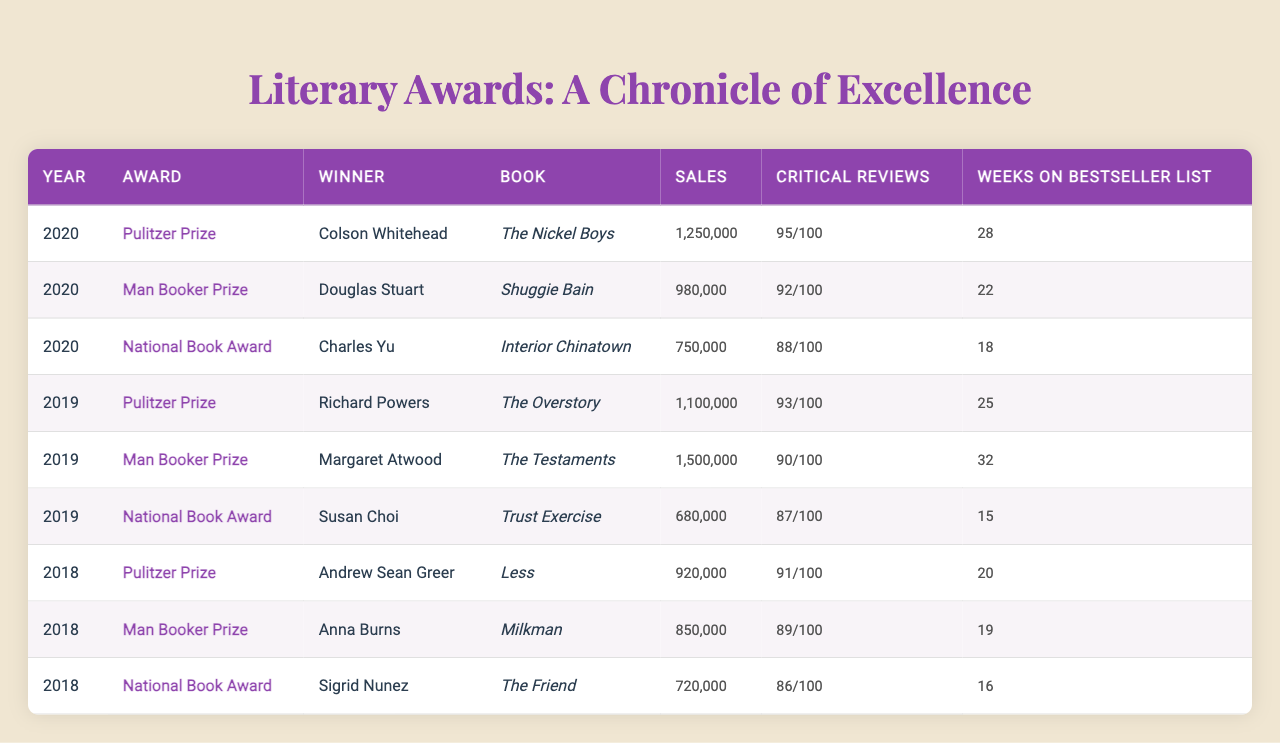What book won the Pulitzer Prize in 2020? In the table, I can see that the winner of the Pulitzer Prize in 2020 is listed as "Colson Whitehead" with the book "The Nickel Boys."
Answer: The Nickel Boys Which book had the highest sales in 2019? The table shows that "The Testaments" by Margaret Atwood had sales of 1,500,000, which is the highest among all listed books for that year.
Answer: The Testaments How many weeks did "Interior Chinatown" stay on the bestseller list? According to the table, "Interior Chinatown" by Charles Yu stayed on the bestseller list for 18 weeks.
Answer: 18 weeks What is the average sales figure for the National Book Award winners over the three years? To calculate the average, I will sum the sales of the three National Book Award winners: 750,000 + 680,000 + 720,000 = 2,150,000. Then divide by 3: 2,150,000 / 3 = 716,667.
Answer: 716,667 Which author had the highest critical reviews for their book in 2020? By examining the critical reviews for the books in 2020, I see that "The Nickel Boys" by Colson Whitehead received the highest score with 95 reviews.
Answer: Colson Whitehead Did any book win more than one award in the years listed? The table indicates that no individual book is listed as winning multiple awards in the presented years.
Answer: No What is the total number of weeks the winners of the Man Booker Prize spent on the bestseller list across all years? I will sum the weeks on the bestseller list for the Man Booker Prize winners: 22 + 32 + 19 = 73 weeks.
Answer: 73 weeks Which book had a lower sales figure: "Milkman" or "Less"? The table shows "Milkman" had sales of 850,000 while "Less" had sales of 920,000; thus, "Milkman" had the lower sales figure.
Answer: Milkman Who was the winner of the National Book Award in 2018? According to the table, the winner of the National Book Award in 2018 was "Sigrid Nunez" for the book "The Friend."
Answer: Sigrid Nunez What is the percentage difference in sales between the Pulitzer Prize winners in 2019 and 2020? The sales for the Pulitzer Prize winners are 1,100,000 (2019) and 1,250,000 (2020). The difference is 1,250,000 - 1,100,000 = 150,000. To find the percentage difference: (150,000 / 1,100,000) * 100 ≈ 13.64%.
Answer: 13.64% 